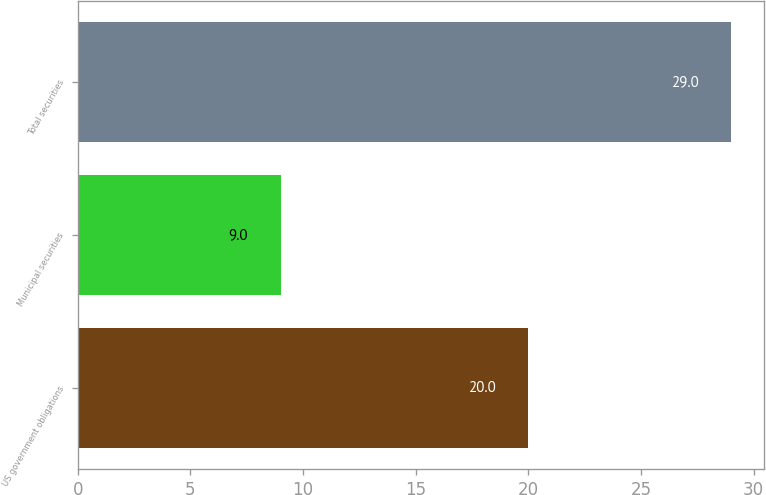<chart> <loc_0><loc_0><loc_500><loc_500><bar_chart><fcel>US government obligations<fcel>Municipal securities<fcel>Total securities<nl><fcel>20<fcel>9<fcel>29<nl></chart> 